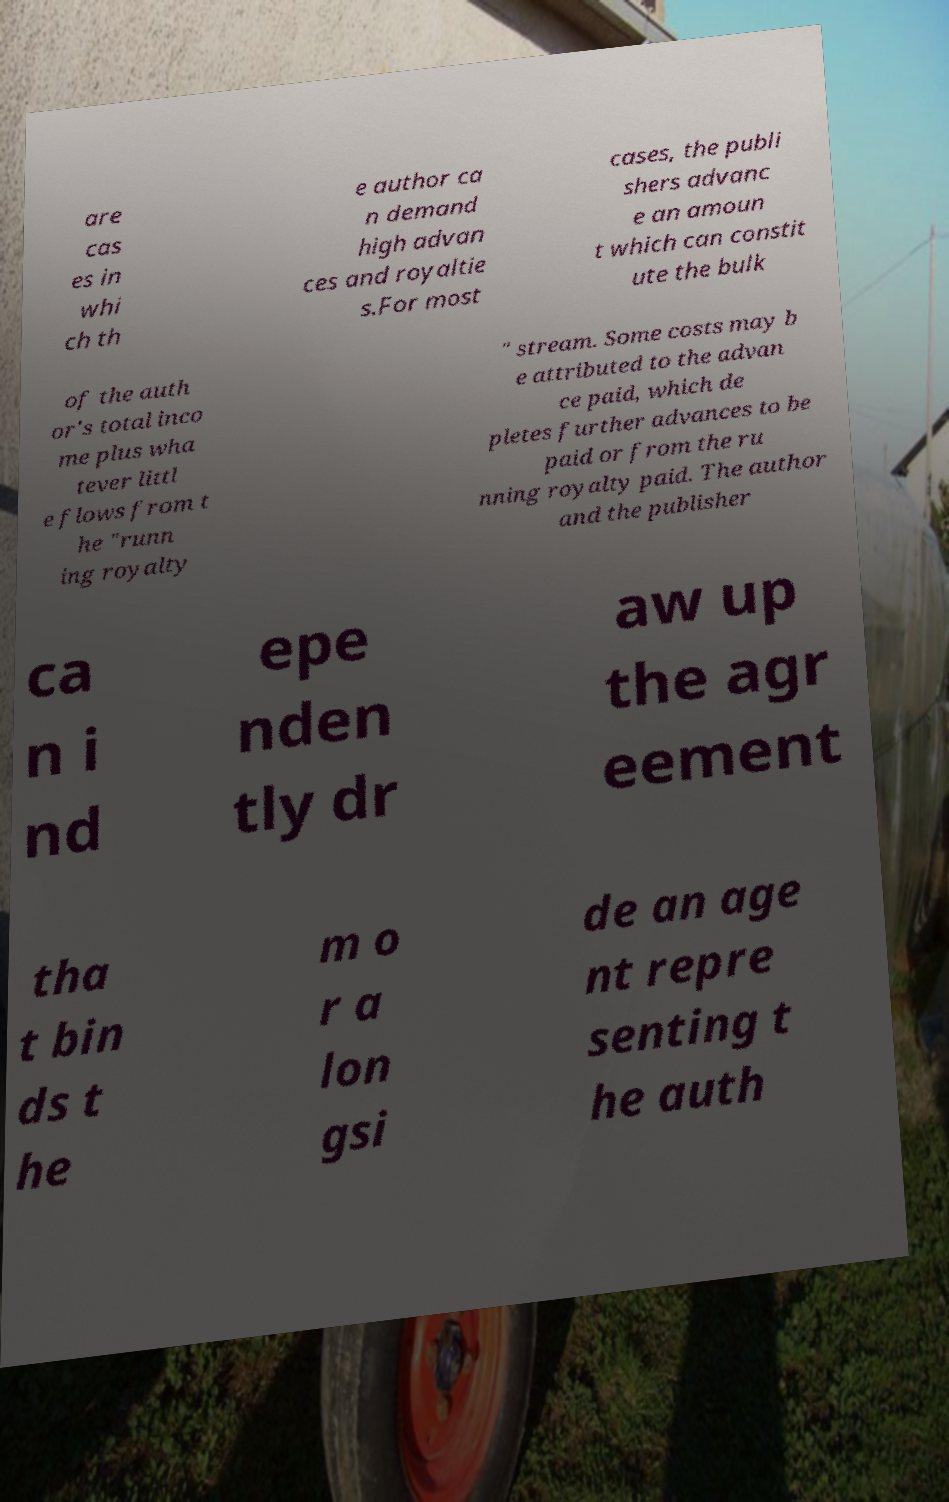I need the written content from this picture converted into text. Can you do that? are cas es in whi ch th e author ca n demand high advan ces and royaltie s.For most cases, the publi shers advanc e an amoun t which can constit ute the bulk of the auth or's total inco me plus wha tever littl e flows from t he "runn ing royalty " stream. Some costs may b e attributed to the advan ce paid, which de pletes further advances to be paid or from the ru nning royalty paid. The author and the publisher ca n i nd epe nden tly dr aw up the agr eement tha t bin ds t he m o r a lon gsi de an age nt repre senting t he auth 